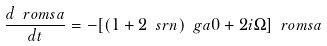<formula> <loc_0><loc_0><loc_500><loc_500>\frac { d \ r o m { s a } } { d t } = - [ ( 1 + 2 \ s r { n } ) \ g a { 0 } + 2 i \Omega ] \ r o m { s a }</formula> 